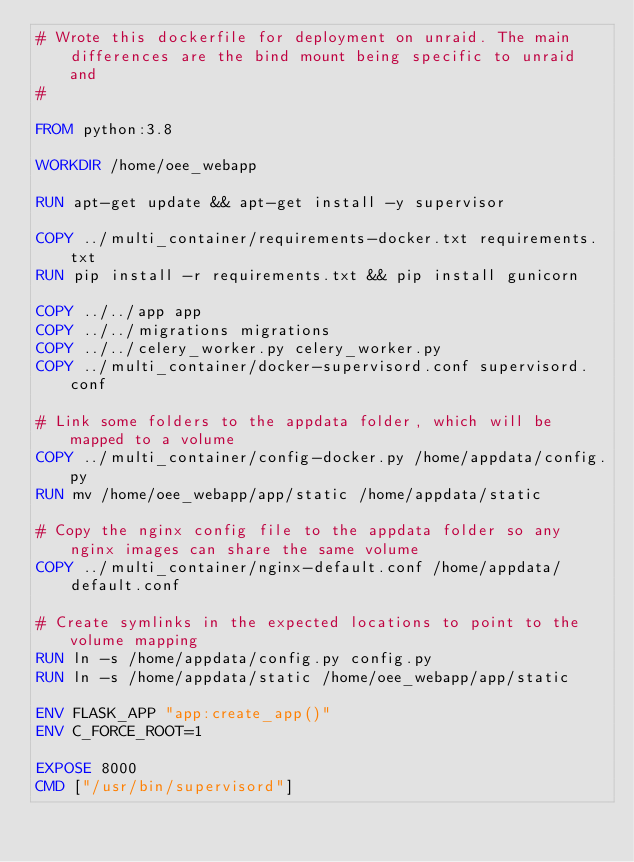Convert code to text. <code><loc_0><loc_0><loc_500><loc_500><_Dockerfile_># Wrote this dockerfile for deployment on unraid. The main differences are the bind mount being specific to unraid and
#

FROM python:3.8

WORKDIR /home/oee_webapp

RUN apt-get update && apt-get install -y supervisor

COPY ../multi_container/requirements-docker.txt requirements.txt
RUN pip install -r requirements.txt && pip install gunicorn

COPY ../../app app
COPY ../../migrations migrations
COPY ../../celery_worker.py celery_worker.py
COPY ../multi_container/docker-supervisord.conf supervisord.conf

# Link some folders to the appdata folder, which will be mapped to a volume
COPY ../multi_container/config-docker.py /home/appdata/config.py
RUN mv /home/oee_webapp/app/static /home/appdata/static

# Copy the nginx config file to the appdata folder so any nginx images can share the same volume
COPY ../multi_container/nginx-default.conf /home/appdata/default.conf

# Create symlinks in the expected locations to point to the volume mapping
RUN ln -s /home/appdata/config.py config.py
RUN ln -s /home/appdata/static /home/oee_webapp/app/static

ENV FLASK_APP "app:create_app()"
ENV C_FORCE_ROOT=1

EXPOSE 8000
CMD ["/usr/bin/supervisord"]
</code> 